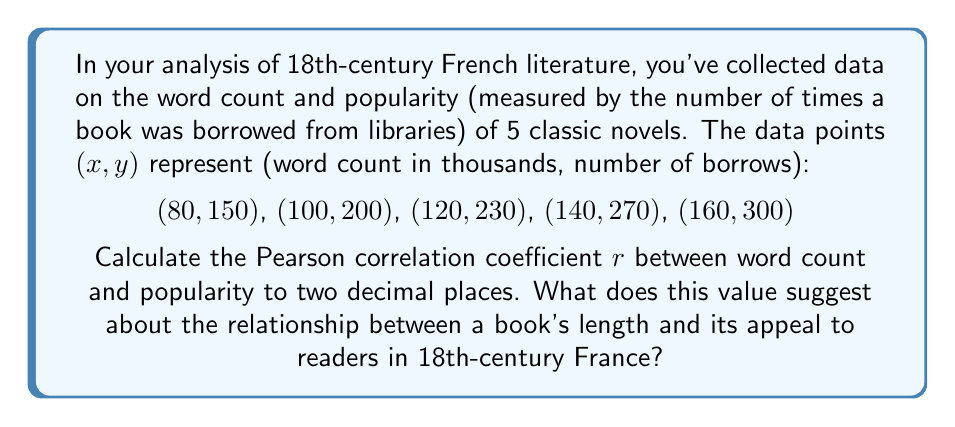What is the answer to this math problem? To calculate the Pearson correlation coefficient, we'll follow these steps:

1. Calculate the means of $x$ and $y$:
   $\bar{x} = \frac{80 + 100 + 120 + 140 + 160}{5} = 120$
   $\bar{y} = \frac{150 + 200 + 230 + 270 + 300}{5} = 230$

2. Calculate the deviations from the means:
   $(x - \bar{x})$: $-40, -20, 0, 20, 40$
   $(y - \bar{y})$: $-80, -30, 0, 40, 70$

3. Calculate the products of the deviations:
   $(x - \bar{x})(y - \bar{y})$: $3200, 600, 0, 800, 2800$

4. Calculate the squares of the deviations:
   $(x - \bar{x})^2$: $1600, 400, 0, 400, 1600$
   $(y - \bar{y})^2$: $6400, 900, 0, 1600, 4900$

5. Sum the results:
   $\sum(x - \bar{x})(y - \bar{y}) = 7400$
   $\sum(x - \bar{x})^2 = 4000$
   $\sum(y - \bar{y})^2 = 13800$

6. Apply the formula for Pearson correlation coefficient:

   $$r = \frac{\sum(x - \bar{x})(y - \bar{y})}{\sqrt{\sum(x - \bar{x})^2 \sum(y - \bar{y})^2}}$$

   $$r = \frac{7400}{\sqrt{4000 \times 13800}} = \frac{7400}{\sqrt{55200000}} \approx 0.9959$$

7. Round to two decimal places: $r = 1.00$

This value suggests a perfect positive linear correlation between a book's word count and its popularity among readers in 18th-century France, implying that longer books were generally more popular.
Answer: $r = 1.00$ 